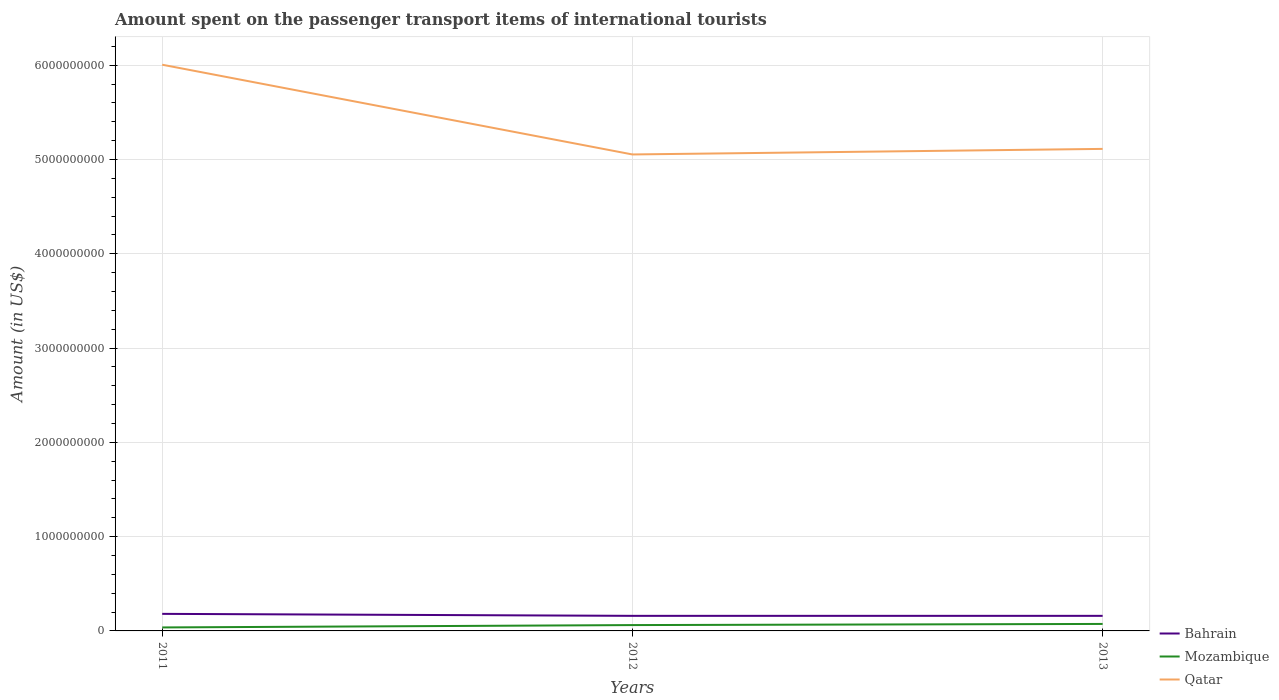How many different coloured lines are there?
Provide a short and direct response. 3. Does the line corresponding to Qatar intersect with the line corresponding to Bahrain?
Provide a short and direct response. No. Across all years, what is the maximum amount spent on the passenger transport items of international tourists in Mozambique?
Give a very brief answer. 3.70e+07. In which year was the amount spent on the passenger transport items of international tourists in Qatar maximum?
Your answer should be very brief. 2012. What is the total amount spent on the passenger transport items of international tourists in Mozambique in the graph?
Provide a short and direct response. -1.20e+07. What is the difference between the highest and the second highest amount spent on the passenger transport items of international tourists in Bahrain?
Give a very brief answer. 2.10e+07. How many years are there in the graph?
Provide a succinct answer. 3. Are the values on the major ticks of Y-axis written in scientific E-notation?
Your answer should be compact. No. Does the graph contain any zero values?
Keep it short and to the point. No. Where does the legend appear in the graph?
Offer a terse response. Bottom right. How many legend labels are there?
Keep it short and to the point. 3. How are the legend labels stacked?
Your answer should be very brief. Vertical. What is the title of the graph?
Keep it short and to the point. Amount spent on the passenger transport items of international tourists. What is the Amount (in US$) in Bahrain in 2011?
Ensure brevity in your answer.  1.81e+08. What is the Amount (in US$) of Mozambique in 2011?
Offer a terse response. 3.70e+07. What is the Amount (in US$) in Qatar in 2011?
Ensure brevity in your answer.  6.01e+09. What is the Amount (in US$) in Bahrain in 2012?
Your answer should be compact. 1.60e+08. What is the Amount (in US$) of Mozambique in 2012?
Provide a short and direct response. 6.20e+07. What is the Amount (in US$) of Qatar in 2012?
Offer a terse response. 5.05e+09. What is the Amount (in US$) of Bahrain in 2013?
Ensure brevity in your answer.  1.60e+08. What is the Amount (in US$) in Mozambique in 2013?
Give a very brief answer. 7.40e+07. What is the Amount (in US$) of Qatar in 2013?
Make the answer very short. 5.11e+09. Across all years, what is the maximum Amount (in US$) in Bahrain?
Keep it short and to the point. 1.81e+08. Across all years, what is the maximum Amount (in US$) in Mozambique?
Provide a succinct answer. 7.40e+07. Across all years, what is the maximum Amount (in US$) of Qatar?
Your response must be concise. 6.01e+09. Across all years, what is the minimum Amount (in US$) of Bahrain?
Offer a terse response. 1.60e+08. Across all years, what is the minimum Amount (in US$) in Mozambique?
Your response must be concise. 3.70e+07. Across all years, what is the minimum Amount (in US$) in Qatar?
Provide a succinct answer. 5.05e+09. What is the total Amount (in US$) of Bahrain in the graph?
Provide a succinct answer. 5.01e+08. What is the total Amount (in US$) in Mozambique in the graph?
Ensure brevity in your answer.  1.73e+08. What is the total Amount (in US$) in Qatar in the graph?
Your answer should be very brief. 1.62e+1. What is the difference between the Amount (in US$) of Bahrain in 2011 and that in 2012?
Keep it short and to the point. 2.10e+07. What is the difference between the Amount (in US$) in Mozambique in 2011 and that in 2012?
Your answer should be very brief. -2.50e+07. What is the difference between the Amount (in US$) in Qatar in 2011 and that in 2012?
Offer a terse response. 9.52e+08. What is the difference between the Amount (in US$) of Bahrain in 2011 and that in 2013?
Make the answer very short. 2.10e+07. What is the difference between the Amount (in US$) of Mozambique in 2011 and that in 2013?
Provide a short and direct response. -3.70e+07. What is the difference between the Amount (in US$) of Qatar in 2011 and that in 2013?
Keep it short and to the point. 8.93e+08. What is the difference between the Amount (in US$) in Bahrain in 2012 and that in 2013?
Your response must be concise. 0. What is the difference between the Amount (in US$) in Mozambique in 2012 and that in 2013?
Ensure brevity in your answer.  -1.20e+07. What is the difference between the Amount (in US$) of Qatar in 2012 and that in 2013?
Offer a very short reply. -5.90e+07. What is the difference between the Amount (in US$) in Bahrain in 2011 and the Amount (in US$) in Mozambique in 2012?
Offer a terse response. 1.19e+08. What is the difference between the Amount (in US$) in Bahrain in 2011 and the Amount (in US$) in Qatar in 2012?
Give a very brief answer. -4.87e+09. What is the difference between the Amount (in US$) in Mozambique in 2011 and the Amount (in US$) in Qatar in 2012?
Give a very brief answer. -5.02e+09. What is the difference between the Amount (in US$) in Bahrain in 2011 and the Amount (in US$) in Mozambique in 2013?
Offer a very short reply. 1.07e+08. What is the difference between the Amount (in US$) of Bahrain in 2011 and the Amount (in US$) of Qatar in 2013?
Make the answer very short. -4.93e+09. What is the difference between the Amount (in US$) in Mozambique in 2011 and the Amount (in US$) in Qatar in 2013?
Make the answer very short. -5.08e+09. What is the difference between the Amount (in US$) in Bahrain in 2012 and the Amount (in US$) in Mozambique in 2013?
Your answer should be very brief. 8.60e+07. What is the difference between the Amount (in US$) of Bahrain in 2012 and the Amount (in US$) of Qatar in 2013?
Offer a very short reply. -4.95e+09. What is the difference between the Amount (in US$) of Mozambique in 2012 and the Amount (in US$) of Qatar in 2013?
Your answer should be compact. -5.05e+09. What is the average Amount (in US$) of Bahrain per year?
Keep it short and to the point. 1.67e+08. What is the average Amount (in US$) in Mozambique per year?
Provide a short and direct response. 5.77e+07. What is the average Amount (in US$) in Qatar per year?
Offer a terse response. 5.39e+09. In the year 2011, what is the difference between the Amount (in US$) of Bahrain and Amount (in US$) of Mozambique?
Offer a very short reply. 1.44e+08. In the year 2011, what is the difference between the Amount (in US$) in Bahrain and Amount (in US$) in Qatar?
Provide a succinct answer. -5.82e+09. In the year 2011, what is the difference between the Amount (in US$) in Mozambique and Amount (in US$) in Qatar?
Make the answer very short. -5.97e+09. In the year 2012, what is the difference between the Amount (in US$) of Bahrain and Amount (in US$) of Mozambique?
Keep it short and to the point. 9.80e+07. In the year 2012, what is the difference between the Amount (in US$) of Bahrain and Amount (in US$) of Qatar?
Keep it short and to the point. -4.89e+09. In the year 2012, what is the difference between the Amount (in US$) in Mozambique and Amount (in US$) in Qatar?
Provide a short and direct response. -4.99e+09. In the year 2013, what is the difference between the Amount (in US$) of Bahrain and Amount (in US$) of Mozambique?
Keep it short and to the point. 8.60e+07. In the year 2013, what is the difference between the Amount (in US$) of Bahrain and Amount (in US$) of Qatar?
Give a very brief answer. -4.95e+09. In the year 2013, what is the difference between the Amount (in US$) in Mozambique and Amount (in US$) in Qatar?
Make the answer very short. -5.04e+09. What is the ratio of the Amount (in US$) of Bahrain in 2011 to that in 2012?
Give a very brief answer. 1.13. What is the ratio of the Amount (in US$) in Mozambique in 2011 to that in 2012?
Ensure brevity in your answer.  0.6. What is the ratio of the Amount (in US$) in Qatar in 2011 to that in 2012?
Keep it short and to the point. 1.19. What is the ratio of the Amount (in US$) in Bahrain in 2011 to that in 2013?
Keep it short and to the point. 1.13. What is the ratio of the Amount (in US$) in Qatar in 2011 to that in 2013?
Ensure brevity in your answer.  1.17. What is the ratio of the Amount (in US$) of Mozambique in 2012 to that in 2013?
Offer a very short reply. 0.84. What is the ratio of the Amount (in US$) in Qatar in 2012 to that in 2013?
Provide a succinct answer. 0.99. What is the difference between the highest and the second highest Amount (in US$) of Bahrain?
Your answer should be compact. 2.10e+07. What is the difference between the highest and the second highest Amount (in US$) in Qatar?
Offer a very short reply. 8.93e+08. What is the difference between the highest and the lowest Amount (in US$) of Bahrain?
Your answer should be very brief. 2.10e+07. What is the difference between the highest and the lowest Amount (in US$) of Mozambique?
Your response must be concise. 3.70e+07. What is the difference between the highest and the lowest Amount (in US$) of Qatar?
Your response must be concise. 9.52e+08. 